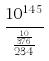<formula> <loc_0><loc_0><loc_500><loc_500>\frac { 1 0 ^ { 1 4 5 } } { \frac { \frac { 1 0 } { 3 7 6 } } { 2 3 4 } }</formula> 